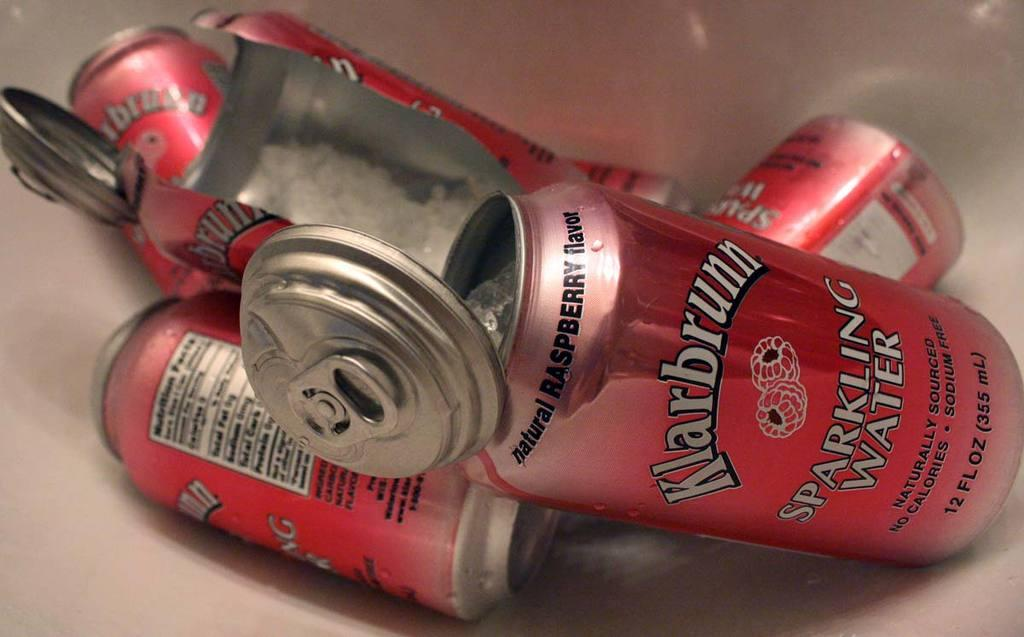<image>
Render a clear and concise summary of the photo. Several cans that are cut open and labeled as sparkling water. 